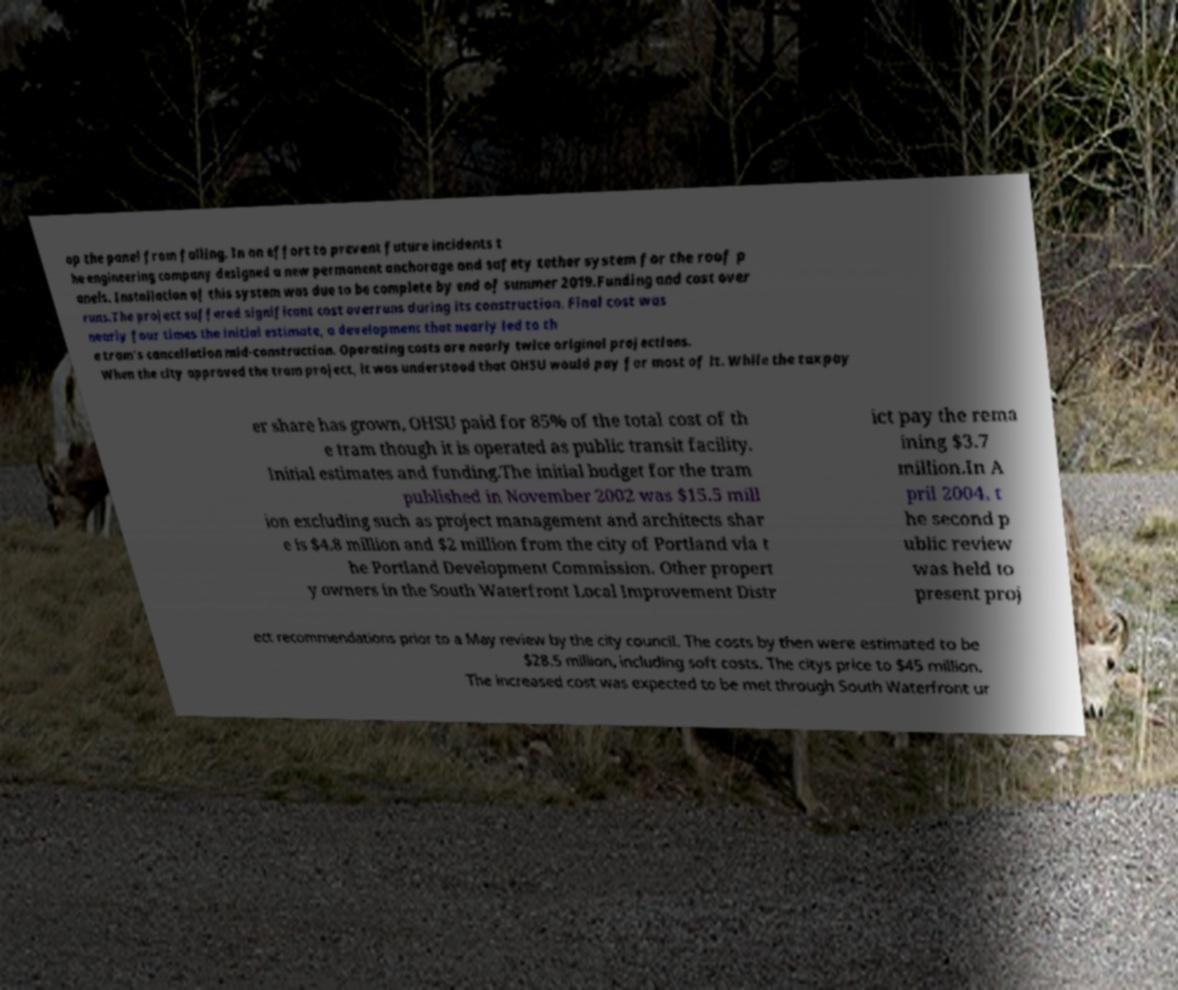What messages or text are displayed in this image? I need them in a readable, typed format. op the panel from falling. In an effort to prevent future incidents t he engineering company designed a new permanent anchorage and safety tether system for the roof p anels. Installation of this system was due to be complete by end of summer 2019.Funding and cost over runs.The project suffered significant cost overruns during its construction. Final cost was nearly four times the initial estimate, a development that nearly led to th e tram's cancellation mid-construction. Operating costs are nearly twice original projections. When the city approved the tram project, it was understood that OHSU would pay for most of it. While the taxpay er share has grown, OHSU paid for 85% of the total cost of th e tram though it is operated as public transit facility. Initial estimates and funding.The initial budget for the tram published in November 2002 was $15.5 mill ion excluding such as project management and architects shar e is $4.8 million and $2 million from the city of Portland via t he Portland Development Commission. Other propert y owners in the South Waterfront Local Improvement Distr ict pay the rema ining $3.7 million.In A pril 2004, t he second p ublic review was held to present proj ect recommendations prior to a May review by the city council. The costs by then were estimated to be $28.5 million, including soft costs. The citys price to $45 million. The increased cost was expected to be met through South Waterfront ur 